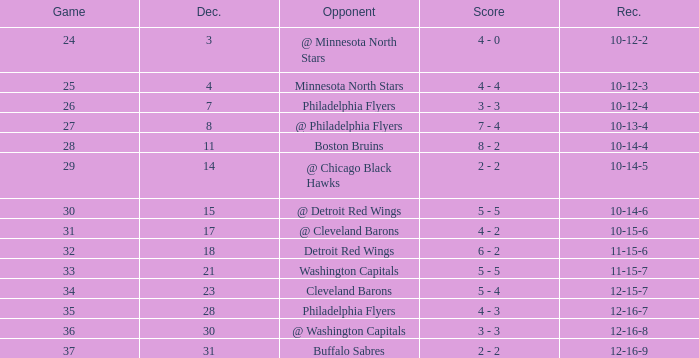What is Record, when Game is "24"? 10-12-2. 